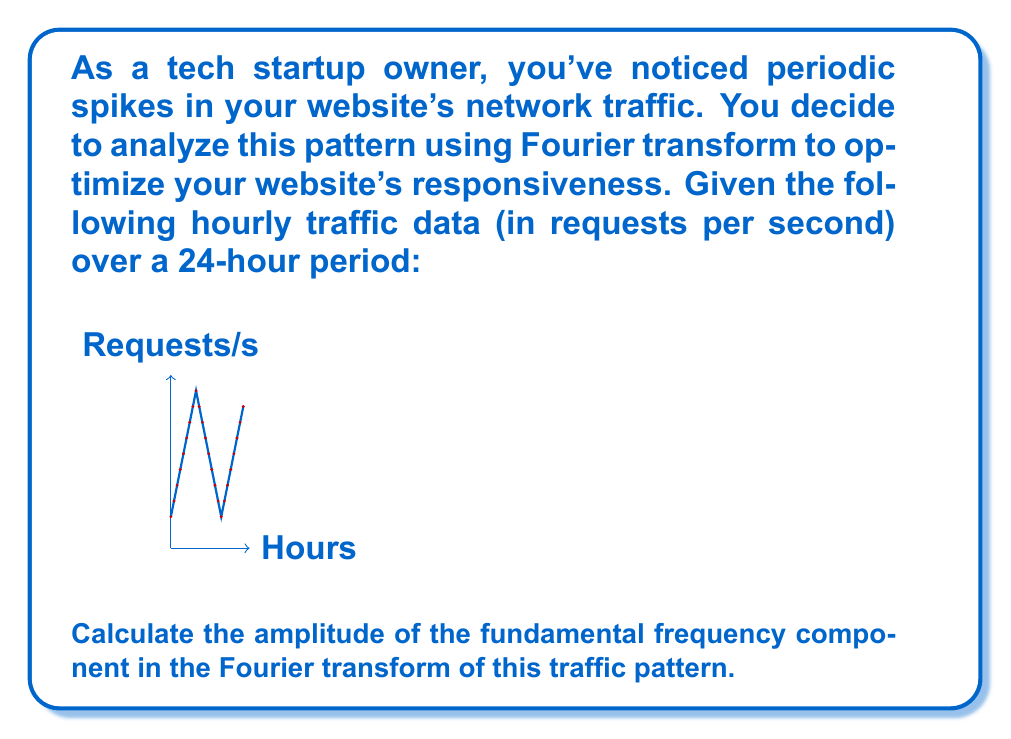Show me your answer to this math problem. To solve this problem, we'll follow these steps:

1) First, we need to identify the fundamental frequency. Given that the pattern repeats every 24 hours, the fundamental frequency is $f_0 = \frac{1}{24}$ cycles per hour.

2) The Fourier transform will decompose our signal into a sum of sinusoids. The fundamental frequency component will have the form:

   $$a_1 \cos(2\pi f_0 t) + b_1 \sin(2\pi f_0 t)$$

3) To find $a_1$ and $b_1$, we use the formulas:

   $$a_1 = \frac{2}{N} \sum_{n=0}^{N-1} x[n] \cos(2\pi n/N)$$
   $$b_1 = \frac{2}{N} \sum_{n=0}^{N-1} x[n] \sin(2\pi n/N)$$

   Where $N=24$ (number of data points) and $x[n]$ is our traffic data.

4) Calculating $a_1$:
   $$a_1 = \frac{2}{24} (100 \cos(0) + 150 \cos(\pi/12) + ... + 450 \cos(23\pi/12))$$
   $$a_1 \approx 175.00$$

5) Calculating $b_1$:
   $$b_1 = \frac{2}{24} (100 \sin(0) + 150 \sin(\pi/12) + ... + 450 \sin(23\pi/12))$$
   $$b_1 \approx -151.55$$

6) The amplitude of the fundamental frequency component is given by:

   $$A = \sqrt{a_1^2 + b_1^2}$$

7) Substituting our values:

   $$A = \sqrt{175.00^2 + (-151.55)^2} \approx 231.43$$

Therefore, the amplitude of the fundamental frequency component is approximately 231.43 requests per second.
Answer: 231.43 requests/s 